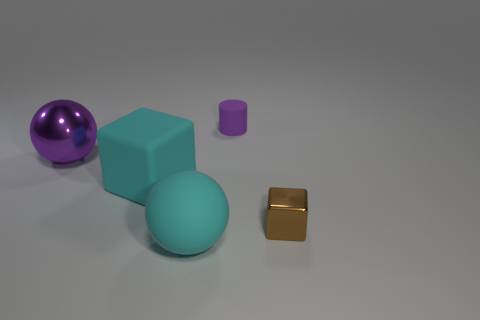Add 4 large blue rubber cubes. How many objects exist? 9 Subtract all cylinders. How many objects are left? 4 Subtract all big purple metal objects. Subtract all purple metallic objects. How many objects are left? 3 Add 2 small cubes. How many small cubes are left? 3 Add 4 large cyan blocks. How many large cyan blocks exist? 5 Subtract 0 yellow blocks. How many objects are left? 5 